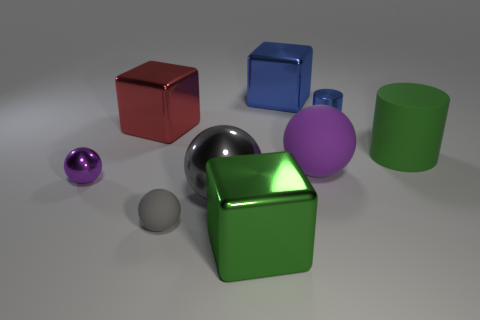What might be the size of these objects relative to each other? The objects vary in size relative to each other. The red and blue cubes, as well as the green cylinder, appear to be similar in scale, likely within a few inches or centimeters of each other. The purple and smaller green spheres are significantly smaller in comparison, perhaps only a fraction of the size of the cubes, and the chrome sphere is slightly larger than the cubes. 